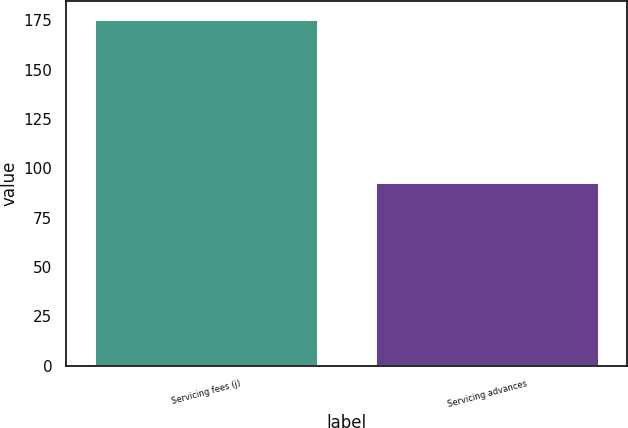<chart> <loc_0><loc_0><loc_500><loc_500><bar_chart><fcel>Servicing fees (j)<fcel>Servicing advances<nl><fcel>176<fcel>93<nl></chart> 